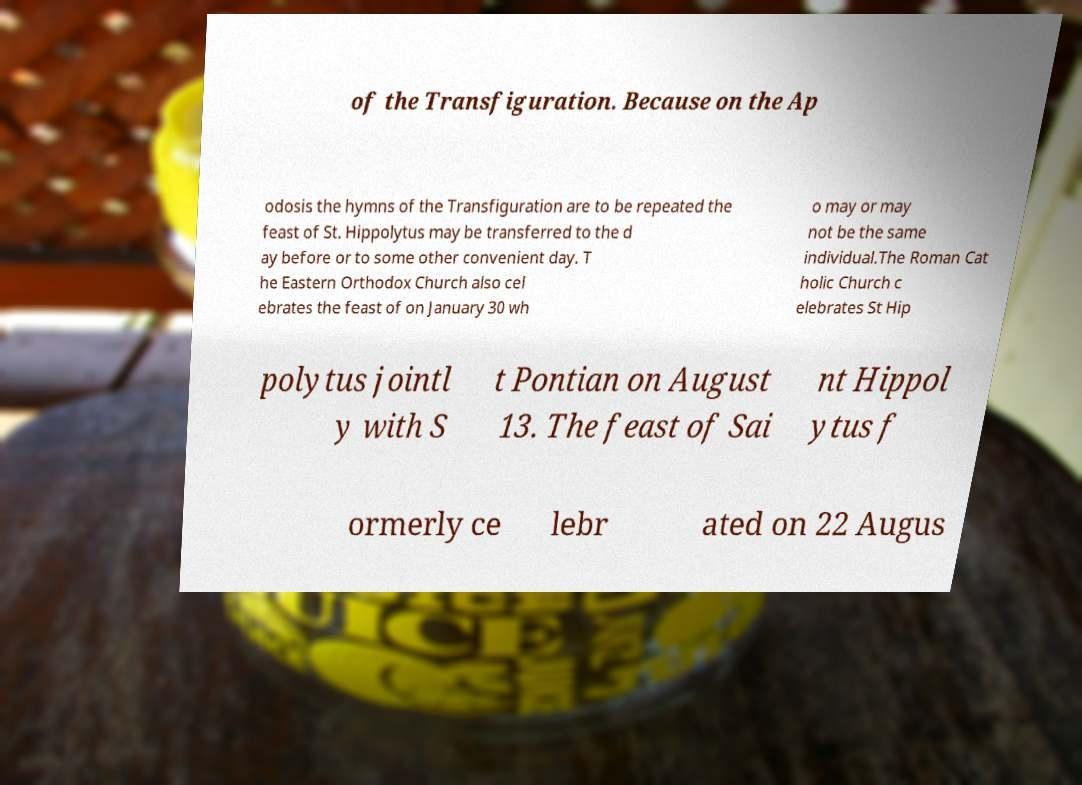What messages or text are displayed in this image? I need them in a readable, typed format. of the Transfiguration. Because on the Ap odosis the hymns of the Transfiguration are to be repeated the feast of St. Hippolytus may be transferred to the d ay before or to some other convenient day. T he Eastern Orthodox Church also cel ebrates the feast of on January 30 wh o may or may not be the same individual.The Roman Cat holic Church c elebrates St Hip polytus jointl y with S t Pontian on August 13. The feast of Sai nt Hippol ytus f ormerly ce lebr ated on 22 Augus 